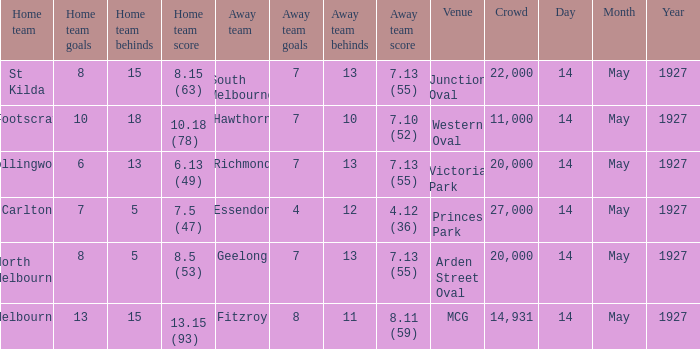12 (36)? Essendon. 